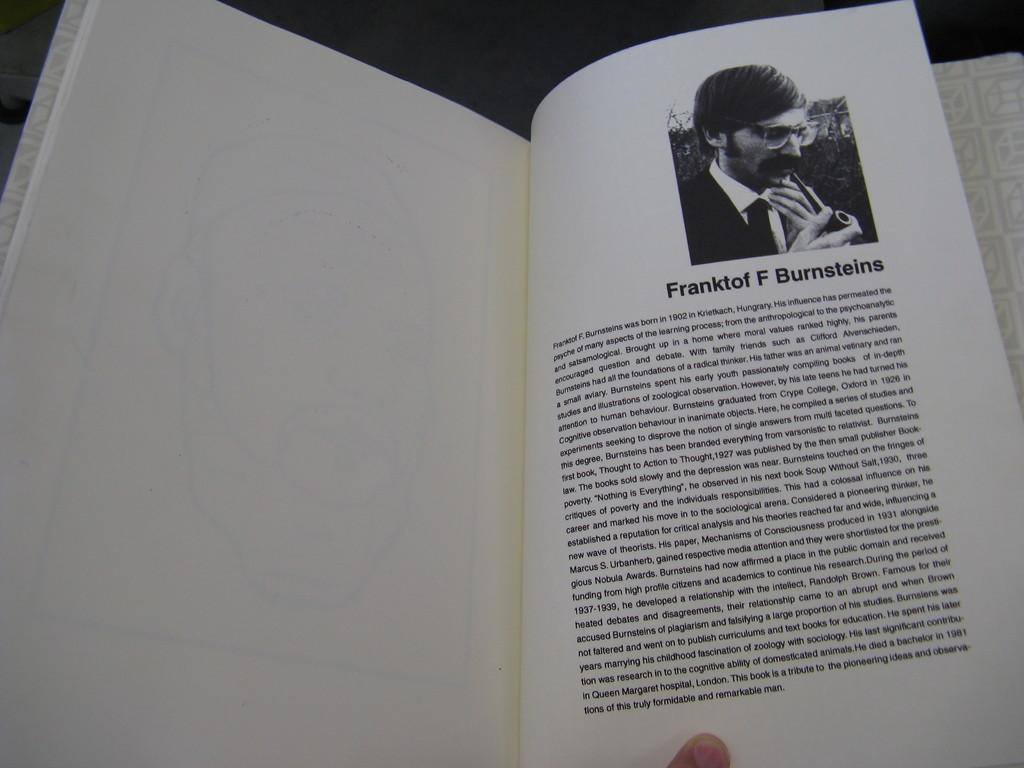<image>
Share a concise interpretation of the image provided. A page in a book about "Franktof F Burnsteins". 